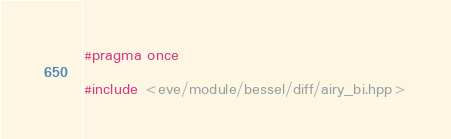<code> <loc_0><loc_0><loc_500><loc_500><_C++_>#pragma once

#include <eve/module/bessel/diff/airy_bi.hpp>
</code> 